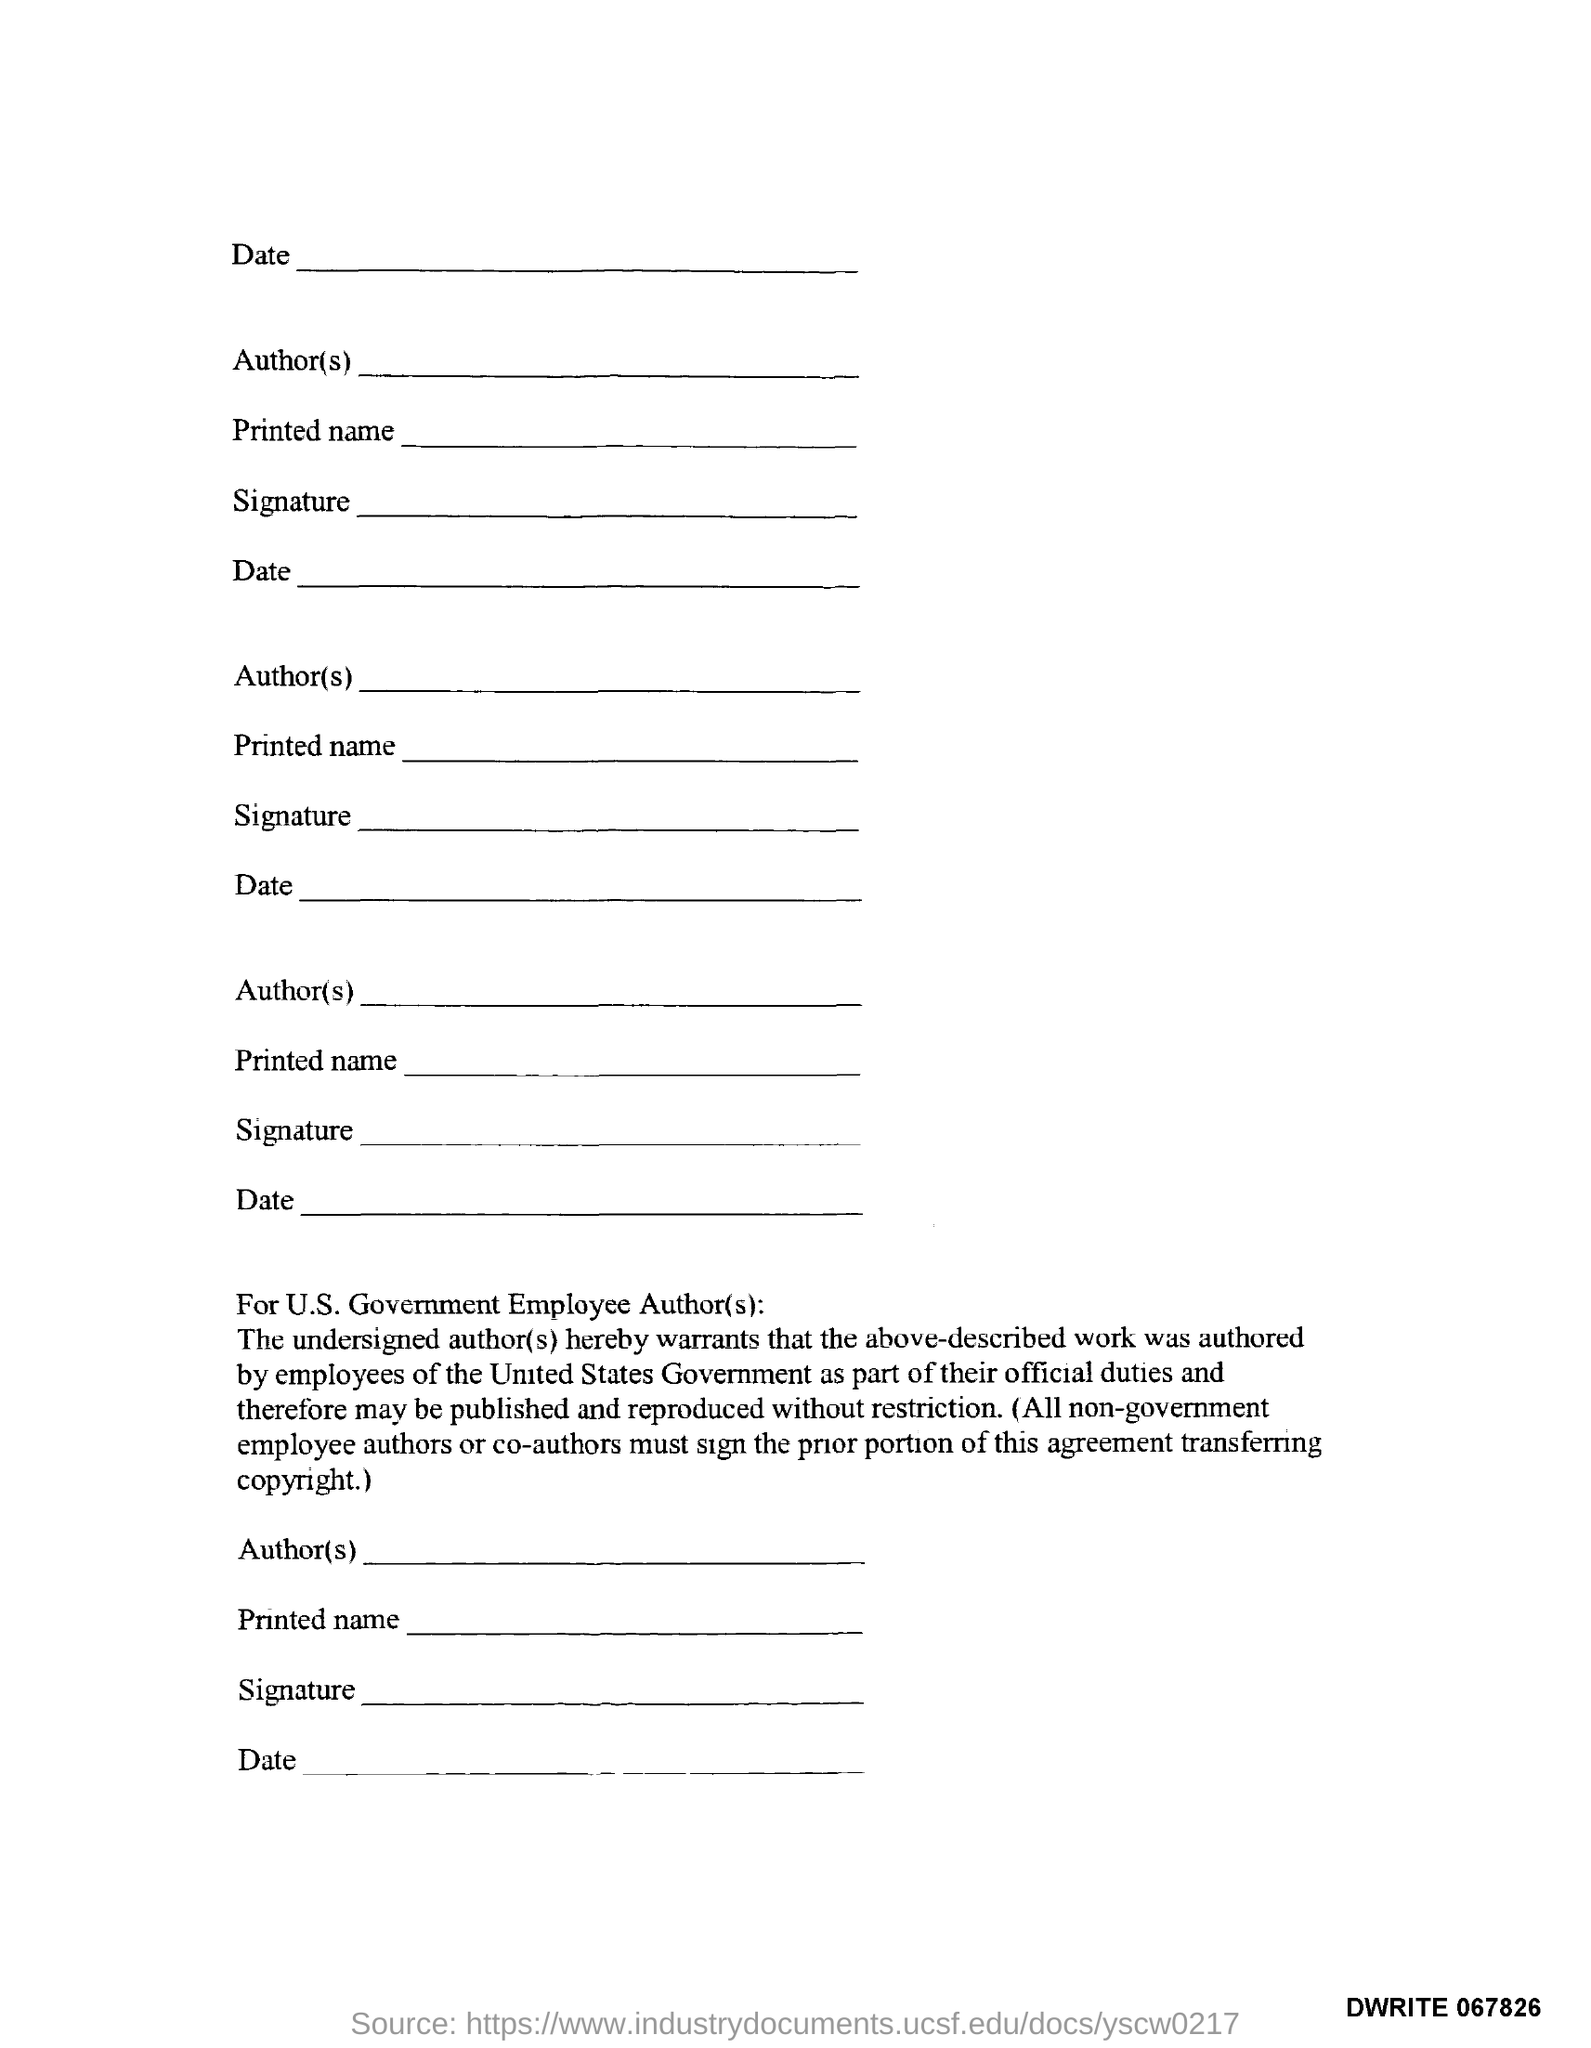Mention a couple of crucial points in this snapshot. The document number is DWRITE 067826. 